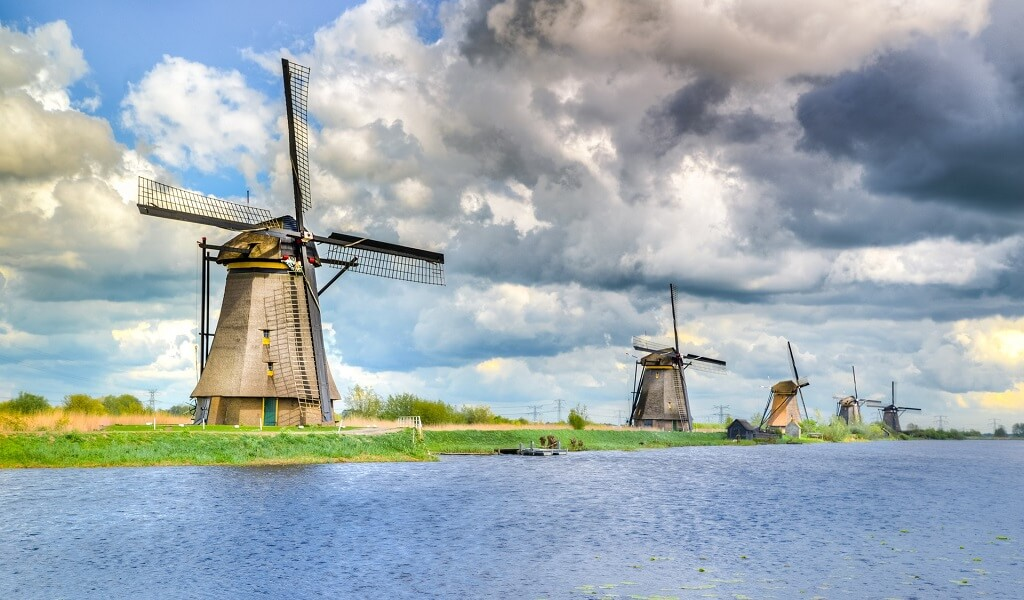Describe the kind of weather you think is depicted in the image. The weather in the image appears to be a mix of sunshine and impending rain. While the sky is predominantly blue and dotted with fluffy, white clouds, there are also darker, more ominous clouds gathering, suggesting that rain might be on the horizon. This contrast adds a dynamic and somewhat dramatic feel to the scene, hinting at the ever-changing nature of weather in the region. What's the atmosphere like in this scene? The atmosphere in the image is deeply tranquil and inviting, yet there's an underlying sense of movement due to the changing weather. The windmills stand tall and steadfast, embodying a timeless stability amidst the natural ebb and flow of the environment. The gentle ripples on the canal and the play of light and shadow across the landscape enhance the serene yet slightly dynamic mood, encapsulating the beauty of a typical day in the Dutch countryside with an air of calm anticipation of the coming rain. 